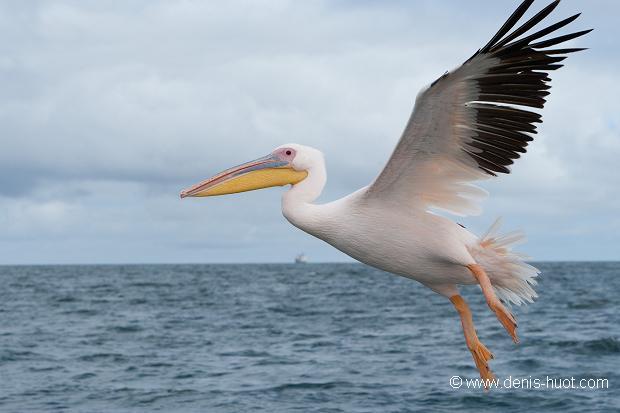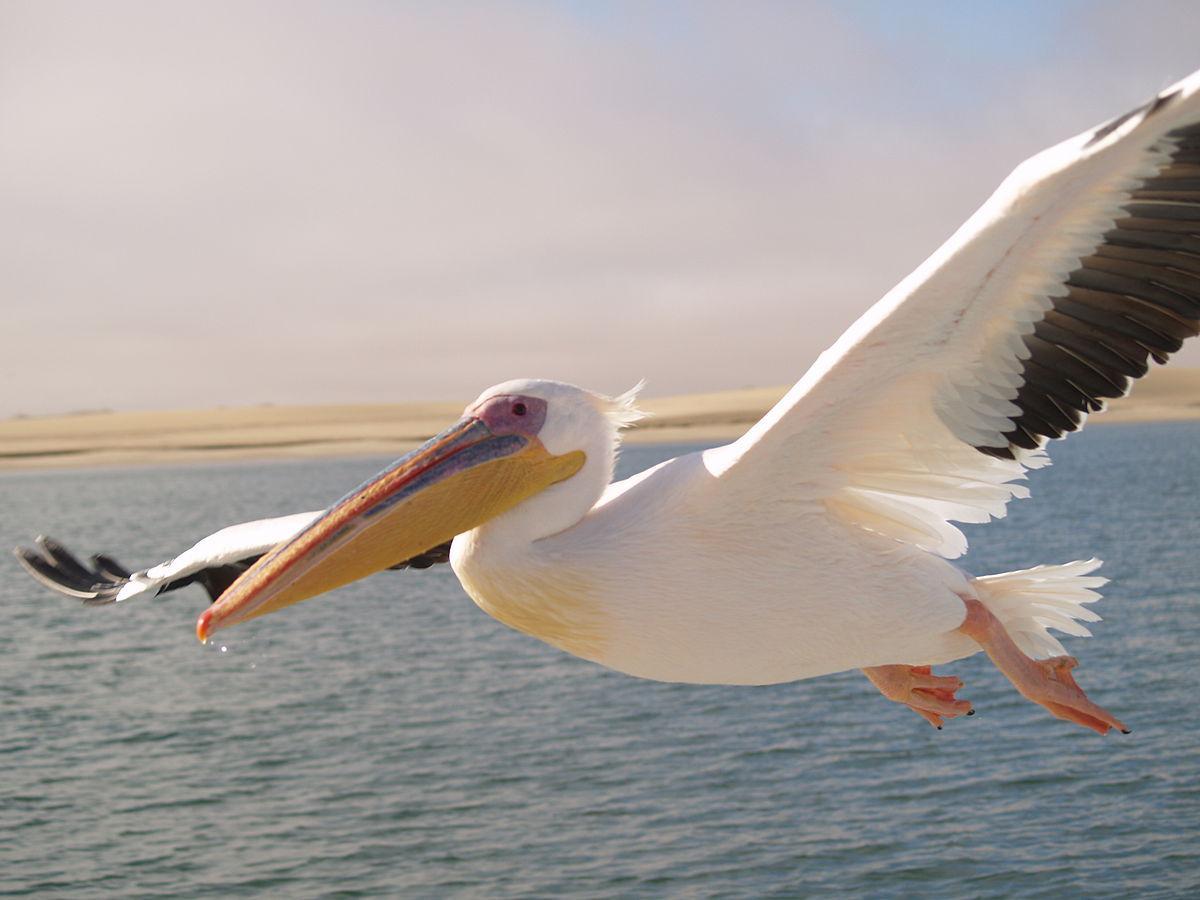The first image is the image on the left, the second image is the image on the right. For the images shown, is this caption "There are two pelicans flying" true? Answer yes or no. Yes. 